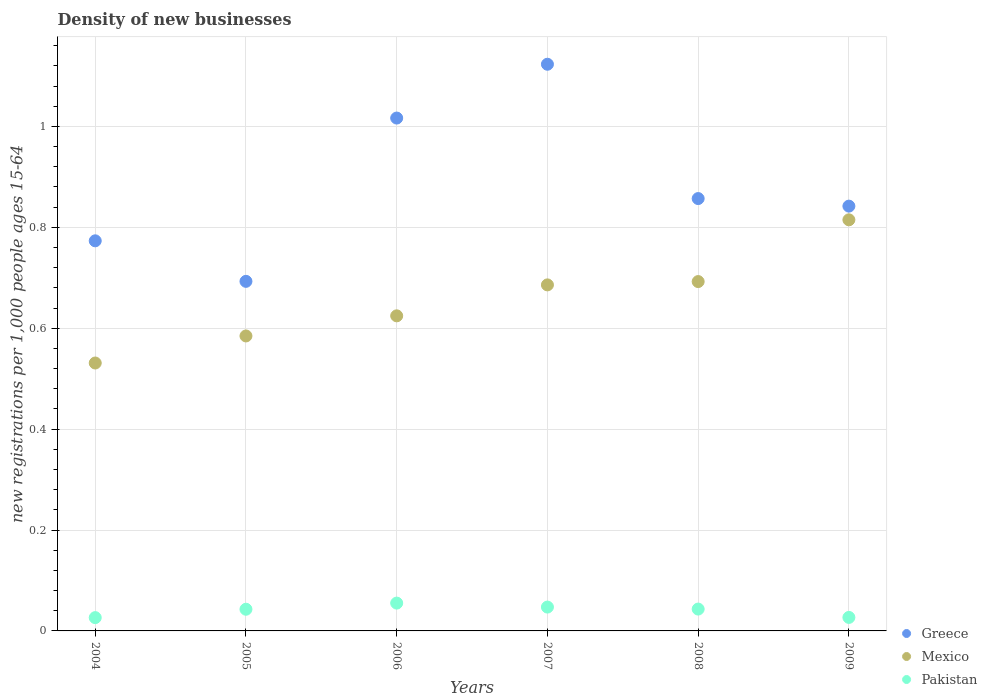How many different coloured dotlines are there?
Make the answer very short. 3. What is the number of new registrations in Greece in 2004?
Give a very brief answer. 0.77. Across all years, what is the maximum number of new registrations in Mexico?
Your answer should be very brief. 0.81. Across all years, what is the minimum number of new registrations in Mexico?
Keep it short and to the point. 0.53. In which year was the number of new registrations in Mexico minimum?
Give a very brief answer. 2004. What is the total number of new registrations in Pakistan in the graph?
Provide a succinct answer. 0.24. What is the difference between the number of new registrations in Mexico in 2005 and that in 2007?
Offer a terse response. -0.1. What is the difference between the number of new registrations in Mexico in 2009 and the number of new registrations in Pakistan in 2008?
Give a very brief answer. 0.77. What is the average number of new registrations in Pakistan per year?
Your response must be concise. 0.04. In the year 2008, what is the difference between the number of new registrations in Greece and number of new registrations in Pakistan?
Give a very brief answer. 0.81. In how many years, is the number of new registrations in Greece greater than 0.6000000000000001?
Keep it short and to the point. 6. What is the ratio of the number of new registrations in Greece in 2004 to that in 2009?
Ensure brevity in your answer.  0.92. What is the difference between the highest and the second highest number of new registrations in Greece?
Provide a short and direct response. 0.11. What is the difference between the highest and the lowest number of new registrations in Mexico?
Your response must be concise. 0.28. In how many years, is the number of new registrations in Pakistan greater than the average number of new registrations in Pakistan taken over all years?
Provide a succinct answer. 4. Is the sum of the number of new registrations in Pakistan in 2007 and 2009 greater than the maximum number of new registrations in Mexico across all years?
Offer a terse response. No. Is it the case that in every year, the sum of the number of new registrations in Mexico and number of new registrations in Pakistan  is greater than the number of new registrations in Greece?
Offer a very short reply. No. Does the number of new registrations in Mexico monotonically increase over the years?
Make the answer very short. Yes. Is the number of new registrations in Pakistan strictly greater than the number of new registrations in Greece over the years?
Offer a very short reply. No. Is the number of new registrations in Greece strictly less than the number of new registrations in Mexico over the years?
Provide a succinct answer. No. How many dotlines are there?
Ensure brevity in your answer.  3. How many years are there in the graph?
Make the answer very short. 6. What is the difference between two consecutive major ticks on the Y-axis?
Offer a terse response. 0.2. Are the values on the major ticks of Y-axis written in scientific E-notation?
Provide a succinct answer. No. Does the graph contain any zero values?
Make the answer very short. No. Does the graph contain grids?
Make the answer very short. Yes. Where does the legend appear in the graph?
Provide a short and direct response. Bottom right. How many legend labels are there?
Give a very brief answer. 3. What is the title of the graph?
Provide a succinct answer. Density of new businesses. What is the label or title of the X-axis?
Provide a succinct answer. Years. What is the label or title of the Y-axis?
Offer a very short reply. New registrations per 1,0 people ages 15-64. What is the new registrations per 1,000 people ages 15-64 in Greece in 2004?
Your answer should be compact. 0.77. What is the new registrations per 1,000 people ages 15-64 of Mexico in 2004?
Offer a terse response. 0.53. What is the new registrations per 1,000 people ages 15-64 in Pakistan in 2004?
Ensure brevity in your answer.  0.03. What is the new registrations per 1,000 people ages 15-64 in Greece in 2005?
Offer a very short reply. 0.69. What is the new registrations per 1,000 people ages 15-64 of Mexico in 2005?
Provide a succinct answer. 0.58. What is the new registrations per 1,000 people ages 15-64 of Pakistan in 2005?
Give a very brief answer. 0.04. What is the new registrations per 1,000 people ages 15-64 of Greece in 2006?
Your answer should be very brief. 1.02. What is the new registrations per 1,000 people ages 15-64 in Mexico in 2006?
Make the answer very short. 0.62. What is the new registrations per 1,000 people ages 15-64 of Pakistan in 2006?
Your answer should be very brief. 0.06. What is the new registrations per 1,000 people ages 15-64 of Greece in 2007?
Your answer should be very brief. 1.12. What is the new registrations per 1,000 people ages 15-64 of Mexico in 2007?
Offer a terse response. 0.69. What is the new registrations per 1,000 people ages 15-64 of Pakistan in 2007?
Your answer should be compact. 0.05. What is the new registrations per 1,000 people ages 15-64 in Greece in 2008?
Your response must be concise. 0.86. What is the new registrations per 1,000 people ages 15-64 in Mexico in 2008?
Offer a terse response. 0.69. What is the new registrations per 1,000 people ages 15-64 in Pakistan in 2008?
Provide a short and direct response. 0.04. What is the new registrations per 1,000 people ages 15-64 in Greece in 2009?
Give a very brief answer. 0.84. What is the new registrations per 1,000 people ages 15-64 in Mexico in 2009?
Your answer should be very brief. 0.81. What is the new registrations per 1,000 people ages 15-64 in Pakistan in 2009?
Your answer should be compact. 0.03. Across all years, what is the maximum new registrations per 1,000 people ages 15-64 in Greece?
Keep it short and to the point. 1.12. Across all years, what is the maximum new registrations per 1,000 people ages 15-64 in Mexico?
Offer a terse response. 0.81. Across all years, what is the maximum new registrations per 1,000 people ages 15-64 of Pakistan?
Your answer should be very brief. 0.06. Across all years, what is the minimum new registrations per 1,000 people ages 15-64 in Greece?
Give a very brief answer. 0.69. Across all years, what is the minimum new registrations per 1,000 people ages 15-64 in Mexico?
Your response must be concise. 0.53. Across all years, what is the minimum new registrations per 1,000 people ages 15-64 in Pakistan?
Make the answer very short. 0.03. What is the total new registrations per 1,000 people ages 15-64 of Greece in the graph?
Offer a very short reply. 5.3. What is the total new registrations per 1,000 people ages 15-64 of Mexico in the graph?
Make the answer very short. 3.93. What is the total new registrations per 1,000 people ages 15-64 in Pakistan in the graph?
Give a very brief answer. 0.24. What is the difference between the new registrations per 1,000 people ages 15-64 in Greece in 2004 and that in 2005?
Offer a terse response. 0.08. What is the difference between the new registrations per 1,000 people ages 15-64 of Mexico in 2004 and that in 2005?
Your answer should be very brief. -0.05. What is the difference between the new registrations per 1,000 people ages 15-64 of Pakistan in 2004 and that in 2005?
Keep it short and to the point. -0.02. What is the difference between the new registrations per 1,000 people ages 15-64 of Greece in 2004 and that in 2006?
Your answer should be very brief. -0.24. What is the difference between the new registrations per 1,000 people ages 15-64 of Mexico in 2004 and that in 2006?
Your answer should be compact. -0.09. What is the difference between the new registrations per 1,000 people ages 15-64 of Pakistan in 2004 and that in 2006?
Make the answer very short. -0.03. What is the difference between the new registrations per 1,000 people ages 15-64 in Greece in 2004 and that in 2007?
Your response must be concise. -0.35. What is the difference between the new registrations per 1,000 people ages 15-64 in Mexico in 2004 and that in 2007?
Your response must be concise. -0.15. What is the difference between the new registrations per 1,000 people ages 15-64 of Pakistan in 2004 and that in 2007?
Your answer should be very brief. -0.02. What is the difference between the new registrations per 1,000 people ages 15-64 of Greece in 2004 and that in 2008?
Give a very brief answer. -0.08. What is the difference between the new registrations per 1,000 people ages 15-64 in Mexico in 2004 and that in 2008?
Provide a short and direct response. -0.16. What is the difference between the new registrations per 1,000 people ages 15-64 of Pakistan in 2004 and that in 2008?
Keep it short and to the point. -0.02. What is the difference between the new registrations per 1,000 people ages 15-64 of Greece in 2004 and that in 2009?
Your answer should be very brief. -0.07. What is the difference between the new registrations per 1,000 people ages 15-64 of Mexico in 2004 and that in 2009?
Provide a short and direct response. -0.28. What is the difference between the new registrations per 1,000 people ages 15-64 of Pakistan in 2004 and that in 2009?
Keep it short and to the point. -0. What is the difference between the new registrations per 1,000 people ages 15-64 in Greece in 2005 and that in 2006?
Offer a terse response. -0.32. What is the difference between the new registrations per 1,000 people ages 15-64 in Mexico in 2005 and that in 2006?
Your response must be concise. -0.04. What is the difference between the new registrations per 1,000 people ages 15-64 of Pakistan in 2005 and that in 2006?
Keep it short and to the point. -0.01. What is the difference between the new registrations per 1,000 people ages 15-64 of Greece in 2005 and that in 2007?
Make the answer very short. -0.43. What is the difference between the new registrations per 1,000 people ages 15-64 in Mexico in 2005 and that in 2007?
Your answer should be compact. -0.1. What is the difference between the new registrations per 1,000 people ages 15-64 of Pakistan in 2005 and that in 2007?
Your response must be concise. -0. What is the difference between the new registrations per 1,000 people ages 15-64 of Greece in 2005 and that in 2008?
Provide a short and direct response. -0.16. What is the difference between the new registrations per 1,000 people ages 15-64 in Mexico in 2005 and that in 2008?
Give a very brief answer. -0.11. What is the difference between the new registrations per 1,000 people ages 15-64 in Pakistan in 2005 and that in 2008?
Give a very brief answer. -0. What is the difference between the new registrations per 1,000 people ages 15-64 of Greece in 2005 and that in 2009?
Your response must be concise. -0.15. What is the difference between the new registrations per 1,000 people ages 15-64 in Mexico in 2005 and that in 2009?
Make the answer very short. -0.23. What is the difference between the new registrations per 1,000 people ages 15-64 of Pakistan in 2005 and that in 2009?
Offer a terse response. 0.02. What is the difference between the new registrations per 1,000 people ages 15-64 in Greece in 2006 and that in 2007?
Provide a succinct answer. -0.11. What is the difference between the new registrations per 1,000 people ages 15-64 of Mexico in 2006 and that in 2007?
Give a very brief answer. -0.06. What is the difference between the new registrations per 1,000 people ages 15-64 in Pakistan in 2006 and that in 2007?
Provide a short and direct response. 0.01. What is the difference between the new registrations per 1,000 people ages 15-64 of Greece in 2006 and that in 2008?
Offer a very short reply. 0.16. What is the difference between the new registrations per 1,000 people ages 15-64 in Mexico in 2006 and that in 2008?
Provide a succinct answer. -0.07. What is the difference between the new registrations per 1,000 people ages 15-64 of Pakistan in 2006 and that in 2008?
Ensure brevity in your answer.  0.01. What is the difference between the new registrations per 1,000 people ages 15-64 in Greece in 2006 and that in 2009?
Offer a terse response. 0.17. What is the difference between the new registrations per 1,000 people ages 15-64 of Mexico in 2006 and that in 2009?
Keep it short and to the point. -0.19. What is the difference between the new registrations per 1,000 people ages 15-64 in Pakistan in 2006 and that in 2009?
Keep it short and to the point. 0.03. What is the difference between the new registrations per 1,000 people ages 15-64 of Greece in 2007 and that in 2008?
Your response must be concise. 0.27. What is the difference between the new registrations per 1,000 people ages 15-64 in Mexico in 2007 and that in 2008?
Provide a short and direct response. -0.01. What is the difference between the new registrations per 1,000 people ages 15-64 in Pakistan in 2007 and that in 2008?
Keep it short and to the point. 0. What is the difference between the new registrations per 1,000 people ages 15-64 of Greece in 2007 and that in 2009?
Your answer should be very brief. 0.28. What is the difference between the new registrations per 1,000 people ages 15-64 of Mexico in 2007 and that in 2009?
Provide a succinct answer. -0.13. What is the difference between the new registrations per 1,000 people ages 15-64 of Pakistan in 2007 and that in 2009?
Provide a succinct answer. 0.02. What is the difference between the new registrations per 1,000 people ages 15-64 in Greece in 2008 and that in 2009?
Provide a short and direct response. 0.01. What is the difference between the new registrations per 1,000 people ages 15-64 of Mexico in 2008 and that in 2009?
Your answer should be very brief. -0.12. What is the difference between the new registrations per 1,000 people ages 15-64 of Pakistan in 2008 and that in 2009?
Offer a terse response. 0.02. What is the difference between the new registrations per 1,000 people ages 15-64 in Greece in 2004 and the new registrations per 1,000 people ages 15-64 in Mexico in 2005?
Your answer should be very brief. 0.19. What is the difference between the new registrations per 1,000 people ages 15-64 of Greece in 2004 and the new registrations per 1,000 people ages 15-64 of Pakistan in 2005?
Your response must be concise. 0.73. What is the difference between the new registrations per 1,000 people ages 15-64 in Mexico in 2004 and the new registrations per 1,000 people ages 15-64 in Pakistan in 2005?
Provide a short and direct response. 0.49. What is the difference between the new registrations per 1,000 people ages 15-64 of Greece in 2004 and the new registrations per 1,000 people ages 15-64 of Mexico in 2006?
Offer a terse response. 0.15. What is the difference between the new registrations per 1,000 people ages 15-64 of Greece in 2004 and the new registrations per 1,000 people ages 15-64 of Pakistan in 2006?
Keep it short and to the point. 0.72. What is the difference between the new registrations per 1,000 people ages 15-64 of Mexico in 2004 and the new registrations per 1,000 people ages 15-64 of Pakistan in 2006?
Offer a very short reply. 0.48. What is the difference between the new registrations per 1,000 people ages 15-64 in Greece in 2004 and the new registrations per 1,000 people ages 15-64 in Mexico in 2007?
Your answer should be compact. 0.09. What is the difference between the new registrations per 1,000 people ages 15-64 in Greece in 2004 and the new registrations per 1,000 people ages 15-64 in Pakistan in 2007?
Offer a terse response. 0.73. What is the difference between the new registrations per 1,000 people ages 15-64 of Mexico in 2004 and the new registrations per 1,000 people ages 15-64 of Pakistan in 2007?
Offer a very short reply. 0.48. What is the difference between the new registrations per 1,000 people ages 15-64 of Greece in 2004 and the new registrations per 1,000 people ages 15-64 of Mexico in 2008?
Provide a succinct answer. 0.08. What is the difference between the new registrations per 1,000 people ages 15-64 in Greece in 2004 and the new registrations per 1,000 people ages 15-64 in Pakistan in 2008?
Ensure brevity in your answer.  0.73. What is the difference between the new registrations per 1,000 people ages 15-64 of Mexico in 2004 and the new registrations per 1,000 people ages 15-64 of Pakistan in 2008?
Offer a terse response. 0.49. What is the difference between the new registrations per 1,000 people ages 15-64 in Greece in 2004 and the new registrations per 1,000 people ages 15-64 in Mexico in 2009?
Your answer should be very brief. -0.04. What is the difference between the new registrations per 1,000 people ages 15-64 in Greece in 2004 and the new registrations per 1,000 people ages 15-64 in Pakistan in 2009?
Your answer should be very brief. 0.75. What is the difference between the new registrations per 1,000 people ages 15-64 in Mexico in 2004 and the new registrations per 1,000 people ages 15-64 in Pakistan in 2009?
Provide a short and direct response. 0.5. What is the difference between the new registrations per 1,000 people ages 15-64 of Greece in 2005 and the new registrations per 1,000 people ages 15-64 of Mexico in 2006?
Offer a terse response. 0.07. What is the difference between the new registrations per 1,000 people ages 15-64 in Greece in 2005 and the new registrations per 1,000 people ages 15-64 in Pakistan in 2006?
Your answer should be compact. 0.64. What is the difference between the new registrations per 1,000 people ages 15-64 in Mexico in 2005 and the new registrations per 1,000 people ages 15-64 in Pakistan in 2006?
Make the answer very short. 0.53. What is the difference between the new registrations per 1,000 people ages 15-64 of Greece in 2005 and the new registrations per 1,000 people ages 15-64 of Mexico in 2007?
Make the answer very short. 0.01. What is the difference between the new registrations per 1,000 people ages 15-64 in Greece in 2005 and the new registrations per 1,000 people ages 15-64 in Pakistan in 2007?
Make the answer very short. 0.65. What is the difference between the new registrations per 1,000 people ages 15-64 in Mexico in 2005 and the new registrations per 1,000 people ages 15-64 in Pakistan in 2007?
Provide a succinct answer. 0.54. What is the difference between the new registrations per 1,000 people ages 15-64 of Greece in 2005 and the new registrations per 1,000 people ages 15-64 of Pakistan in 2008?
Ensure brevity in your answer.  0.65. What is the difference between the new registrations per 1,000 people ages 15-64 in Mexico in 2005 and the new registrations per 1,000 people ages 15-64 in Pakistan in 2008?
Provide a short and direct response. 0.54. What is the difference between the new registrations per 1,000 people ages 15-64 in Greece in 2005 and the new registrations per 1,000 people ages 15-64 in Mexico in 2009?
Keep it short and to the point. -0.12. What is the difference between the new registrations per 1,000 people ages 15-64 of Greece in 2005 and the new registrations per 1,000 people ages 15-64 of Pakistan in 2009?
Offer a very short reply. 0.67. What is the difference between the new registrations per 1,000 people ages 15-64 of Mexico in 2005 and the new registrations per 1,000 people ages 15-64 of Pakistan in 2009?
Provide a succinct answer. 0.56. What is the difference between the new registrations per 1,000 people ages 15-64 of Greece in 2006 and the new registrations per 1,000 people ages 15-64 of Mexico in 2007?
Provide a short and direct response. 0.33. What is the difference between the new registrations per 1,000 people ages 15-64 of Greece in 2006 and the new registrations per 1,000 people ages 15-64 of Pakistan in 2007?
Give a very brief answer. 0.97. What is the difference between the new registrations per 1,000 people ages 15-64 in Mexico in 2006 and the new registrations per 1,000 people ages 15-64 in Pakistan in 2007?
Your answer should be very brief. 0.58. What is the difference between the new registrations per 1,000 people ages 15-64 of Greece in 2006 and the new registrations per 1,000 people ages 15-64 of Mexico in 2008?
Your answer should be compact. 0.32. What is the difference between the new registrations per 1,000 people ages 15-64 in Greece in 2006 and the new registrations per 1,000 people ages 15-64 in Pakistan in 2008?
Provide a succinct answer. 0.97. What is the difference between the new registrations per 1,000 people ages 15-64 of Mexico in 2006 and the new registrations per 1,000 people ages 15-64 of Pakistan in 2008?
Keep it short and to the point. 0.58. What is the difference between the new registrations per 1,000 people ages 15-64 of Greece in 2006 and the new registrations per 1,000 people ages 15-64 of Mexico in 2009?
Provide a succinct answer. 0.2. What is the difference between the new registrations per 1,000 people ages 15-64 in Mexico in 2006 and the new registrations per 1,000 people ages 15-64 in Pakistan in 2009?
Your response must be concise. 0.6. What is the difference between the new registrations per 1,000 people ages 15-64 of Greece in 2007 and the new registrations per 1,000 people ages 15-64 of Mexico in 2008?
Your answer should be very brief. 0.43. What is the difference between the new registrations per 1,000 people ages 15-64 in Greece in 2007 and the new registrations per 1,000 people ages 15-64 in Pakistan in 2008?
Give a very brief answer. 1.08. What is the difference between the new registrations per 1,000 people ages 15-64 of Mexico in 2007 and the new registrations per 1,000 people ages 15-64 of Pakistan in 2008?
Ensure brevity in your answer.  0.64. What is the difference between the new registrations per 1,000 people ages 15-64 of Greece in 2007 and the new registrations per 1,000 people ages 15-64 of Mexico in 2009?
Your response must be concise. 0.31. What is the difference between the new registrations per 1,000 people ages 15-64 in Greece in 2007 and the new registrations per 1,000 people ages 15-64 in Pakistan in 2009?
Your answer should be very brief. 1.1. What is the difference between the new registrations per 1,000 people ages 15-64 of Mexico in 2007 and the new registrations per 1,000 people ages 15-64 of Pakistan in 2009?
Offer a terse response. 0.66. What is the difference between the new registrations per 1,000 people ages 15-64 in Greece in 2008 and the new registrations per 1,000 people ages 15-64 in Mexico in 2009?
Keep it short and to the point. 0.04. What is the difference between the new registrations per 1,000 people ages 15-64 of Greece in 2008 and the new registrations per 1,000 people ages 15-64 of Pakistan in 2009?
Your answer should be compact. 0.83. What is the difference between the new registrations per 1,000 people ages 15-64 in Mexico in 2008 and the new registrations per 1,000 people ages 15-64 in Pakistan in 2009?
Offer a very short reply. 0.67. What is the average new registrations per 1,000 people ages 15-64 of Greece per year?
Your answer should be very brief. 0.88. What is the average new registrations per 1,000 people ages 15-64 of Mexico per year?
Make the answer very short. 0.66. What is the average new registrations per 1,000 people ages 15-64 of Pakistan per year?
Offer a terse response. 0.04. In the year 2004, what is the difference between the new registrations per 1,000 people ages 15-64 of Greece and new registrations per 1,000 people ages 15-64 of Mexico?
Give a very brief answer. 0.24. In the year 2004, what is the difference between the new registrations per 1,000 people ages 15-64 in Greece and new registrations per 1,000 people ages 15-64 in Pakistan?
Your answer should be compact. 0.75. In the year 2004, what is the difference between the new registrations per 1,000 people ages 15-64 in Mexico and new registrations per 1,000 people ages 15-64 in Pakistan?
Your answer should be compact. 0.5. In the year 2005, what is the difference between the new registrations per 1,000 people ages 15-64 of Greece and new registrations per 1,000 people ages 15-64 of Mexico?
Your answer should be very brief. 0.11. In the year 2005, what is the difference between the new registrations per 1,000 people ages 15-64 in Greece and new registrations per 1,000 people ages 15-64 in Pakistan?
Give a very brief answer. 0.65. In the year 2005, what is the difference between the new registrations per 1,000 people ages 15-64 in Mexico and new registrations per 1,000 people ages 15-64 in Pakistan?
Make the answer very short. 0.54. In the year 2006, what is the difference between the new registrations per 1,000 people ages 15-64 in Greece and new registrations per 1,000 people ages 15-64 in Mexico?
Offer a very short reply. 0.39. In the year 2006, what is the difference between the new registrations per 1,000 people ages 15-64 of Greece and new registrations per 1,000 people ages 15-64 of Pakistan?
Your response must be concise. 0.96. In the year 2006, what is the difference between the new registrations per 1,000 people ages 15-64 in Mexico and new registrations per 1,000 people ages 15-64 in Pakistan?
Provide a succinct answer. 0.57. In the year 2007, what is the difference between the new registrations per 1,000 people ages 15-64 in Greece and new registrations per 1,000 people ages 15-64 in Mexico?
Keep it short and to the point. 0.44. In the year 2007, what is the difference between the new registrations per 1,000 people ages 15-64 in Greece and new registrations per 1,000 people ages 15-64 in Pakistan?
Keep it short and to the point. 1.08. In the year 2007, what is the difference between the new registrations per 1,000 people ages 15-64 in Mexico and new registrations per 1,000 people ages 15-64 in Pakistan?
Provide a short and direct response. 0.64. In the year 2008, what is the difference between the new registrations per 1,000 people ages 15-64 in Greece and new registrations per 1,000 people ages 15-64 in Mexico?
Ensure brevity in your answer.  0.16. In the year 2008, what is the difference between the new registrations per 1,000 people ages 15-64 of Greece and new registrations per 1,000 people ages 15-64 of Pakistan?
Ensure brevity in your answer.  0.81. In the year 2008, what is the difference between the new registrations per 1,000 people ages 15-64 in Mexico and new registrations per 1,000 people ages 15-64 in Pakistan?
Your answer should be compact. 0.65. In the year 2009, what is the difference between the new registrations per 1,000 people ages 15-64 of Greece and new registrations per 1,000 people ages 15-64 of Mexico?
Offer a terse response. 0.03. In the year 2009, what is the difference between the new registrations per 1,000 people ages 15-64 in Greece and new registrations per 1,000 people ages 15-64 in Pakistan?
Your response must be concise. 0.82. In the year 2009, what is the difference between the new registrations per 1,000 people ages 15-64 of Mexico and new registrations per 1,000 people ages 15-64 of Pakistan?
Give a very brief answer. 0.79. What is the ratio of the new registrations per 1,000 people ages 15-64 in Greece in 2004 to that in 2005?
Your answer should be compact. 1.12. What is the ratio of the new registrations per 1,000 people ages 15-64 of Mexico in 2004 to that in 2005?
Ensure brevity in your answer.  0.91. What is the ratio of the new registrations per 1,000 people ages 15-64 of Pakistan in 2004 to that in 2005?
Provide a short and direct response. 0.61. What is the ratio of the new registrations per 1,000 people ages 15-64 of Greece in 2004 to that in 2006?
Your answer should be very brief. 0.76. What is the ratio of the new registrations per 1,000 people ages 15-64 of Mexico in 2004 to that in 2006?
Make the answer very short. 0.85. What is the ratio of the new registrations per 1,000 people ages 15-64 of Pakistan in 2004 to that in 2006?
Provide a short and direct response. 0.48. What is the ratio of the new registrations per 1,000 people ages 15-64 in Greece in 2004 to that in 2007?
Provide a succinct answer. 0.69. What is the ratio of the new registrations per 1,000 people ages 15-64 of Mexico in 2004 to that in 2007?
Offer a very short reply. 0.77. What is the ratio of the new registrations per 1,000 people ages 15-64 of Pakistan in 2004 to that in 2007?
Your answer should be very brief. 0.56. What is the ratio of the new registrations per 1,000 people ages 15-64 in Greece in 2004 to that in 2008?
Your answer should be compact. 0.9. What is the ratio of the new registrations per 1,000 people ages 15-64 in Mexico in 2004 to that in 2008?
Ensure brevity in your answer.  0.77. What is the ratio of the new registrations per 1,000 people ages 15-64 of Pakistan in 2004 to that in 2008?
Provide a short and direct response. 0.61. What is the ratio of the new registrations per 1,000 people ages 15-64 in Greece in 2004 to that in 2009?
Keep it short and to the point. 0.92. What is the ratio of the new registrations per 1,000 people ages 15-64 in Mexico in 2004 to that in 2009?
Provide a short and direct response. 0.65. What is the ratio of the new registrations per 1,000 people ages 15-64 in Pakistan in 2004 to that in 2009?
Make the answer very short. 0.98. What is the ratio of the new registrations per 1,000 people ages 15-64 in Greece in 2005 to that in 2006?
Offer a terse response. 0.68. What is the ratio of the new registrations per 1,000 people ages 15-64 in Mexico in 2005 to that in 2006?
Offer a terse response. 0.94. What is the ratio of the new registrations per 1,000 people ages 15-64 of Pakistan in 2005 to that in 2006?
Provide a short and direct response. 0.78. What is the ratio of the new registrations per 1,000 people ages 15-64 in Greece in 2005 to that in 2007?
Your answer should be compact. 0.62. What is the ratio of the new registrations per 1,000 people ages 15-64 of Mexico in 2005 to that in 2007?
Your answer should be compact. 0.85. What is the ratio of the new registrations per 1,000 people ages 15-64 in Pakistan in 2005 to that in 2007?
Make the answer very short. 0.91. What is the ratio of the new registrations per 1,000 people ages 15-64 in Greece in 2005 to that in 2008?
Provide a short and direct response. 0.81. What is the ratio of the new registrations per 1,000 people ages 15-64 of Mexico in 2005 to that in 2008?
Provide a short and direct response. 0.84. What is the ratio of the new registrations per 1,000 people ages 15-64 of Pakistan in 2005 to that in 2008?
Keep it short and to the point. 0.99. What is the ratio of the new registrations per 1,000 people ages 15-64 in Greece in 2005 to that in 2009?
Keep it short and to the point. 0.82. What is the ratio of the new registrations per 1,000 people ages 15-64 in Mexico in 2005 to that in 2009?
Your answer should be very brief. 0.72. What is the ratio of the new registrations per 1,000 people ages 15-64 in Pakistan in 2005 to that in 2009?
Ensure brevity in your answer.  1.61. What is the ratio of the new registrations per 1,000 people ages 15-64 of Greece in 2006 to that in 2007?
Your answer should be compact. 0.91. What is the ratio of the new registrations per 1,000 people ages 15-64 of Mexico in 2006 to that in 2007?
Your response must be concise. 0.91. What is the ratio of the new registrations per 1,000 people ages 15-64 of Pakistan in 2006 to that in 2007?
Make the answer very short. 1.17. What is the ratio of the new registrations per 1,000 people ages 15-64 in Greece in 2006 to that in 2008?
Offer a terse response. 1.19. What is the ratio of the new registrations per 1,000 people ages 15-64 of Mexico in 2006 to that in 2008?
Your response must be concise. 0.9. What is the ratio of the new registrations per 1,000 people ages 15-64 in Pakistan in 2006 to that in 2008?
Provide a succinct answer. 1.27. What is the ratio of the new registrations per 1,000 people ages 15-64 in Greece in 2006 to that in 2009?
Your answer should be very brief. 1.21. What is the ratio of the new registrations per 1,000 people ages 15-64 of Mexico in 2006 to that in 2009?
Offer a terse response. 0.77. What is the ratio of the new registrations per 1,000 people ages 15-64 in Pakistan in 2006 to that in 2009?
Your response must be concise. 2.06. What is the ratio of the new registrations per 1,000 people ages 15-64 of Greece in 2007 to that in 2008?
Your response must be concise. 1.31. What is the ratio of the new registrations per 1,000 people ages 15-64 of Mexico in 2007 to that in 2008?
Make the answer very short. 0.99. What is the ratio of the new registrations per 1,000 people ages 15-64 of Pakistan in 2007 to that in 2008?
Your answer should be very brief. 1.09. What is the ratio of the new registrations per 1,000 people ages 15-64 of Greece in 2007 to that in 2009?
Offer a very short reply. 1.33. What is the ratio of the new registrations per 1,000 people ages 15-64 of Mexico in 2007 to that in 2009?
Your answer should be compact. 0.84. What is the ratio of the new registrations per 1,000 people ages 15-64 of Pakistan in 2007 to that in 2009?
Your answer should be very brief. 1.77. What is the ratio of the new registrations per 1,000 people ages 15-64 in Greece in 2008 to that in 2009?
Provide a short and direct response. 1.02. What is the ratio of the new registrations per 1,000 people ages 15-64 in Mexico in 2008 to that in 2009?
Provide a short and direct response. 0.85. What is the ratio of the new registrations per 1,000 people ages 15-64 in Pakistan in 2008 to that in 2009?
Offer a very short reply. 1.62. What is the difference between the highest and the second highest new registrations per 1,000 people ages 15-64 in Greece?
Offer a very short reply. 0.11. What is the difference between the highest and the second highest new registrations per 1,000 people ages 15-64 in Mexico?
Make the answer very short. 0.12. What is the difference between the highest and the second highest new registrations per 1,000 people ages 15-64 of Pakistan?
Offer a very short reply. 0.01. What is the difference between the highest and the lowest new registrations per 1,000 people ages 15-64 in Greece?
Your answer should be compact. 0.43. What is the difference between the highest and the lowest new registrations per 1,000 people ages 15-64 in Mexico?
Offer a terse response. 0.28. What is the difference between the highest and the lowest new registrations per 1,000 people ages 15-64 of Pakistan?
Give a very brief answer. 0.03. 